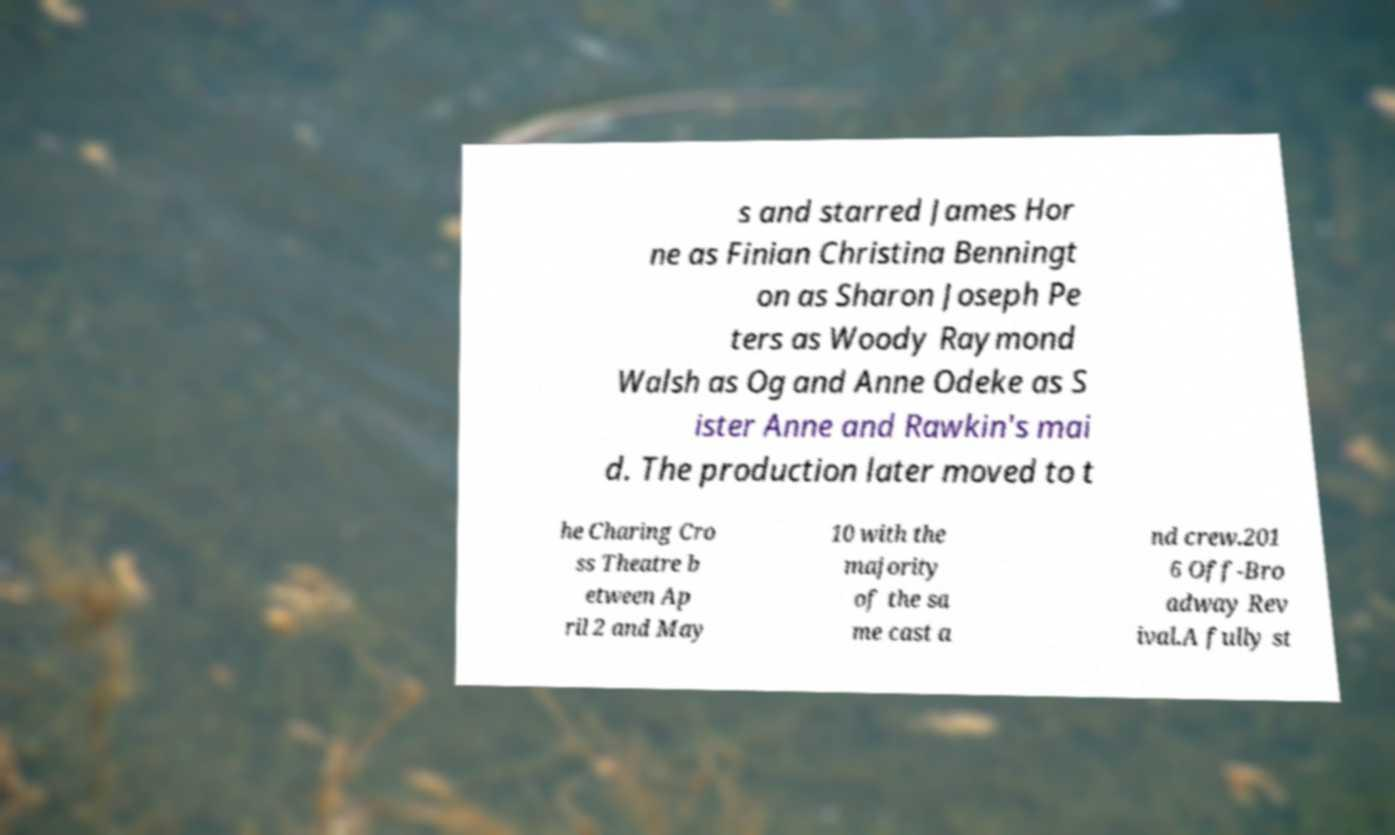Could you assist in decoding the text presented in this image and type it out clearly? s and starred James Hor ne as Finian Christina Benningt on as Sharon Joseph Pe ters as Woody Raymond Walsh as Og and Anne Odeke as S ister Anne and Rawkin's mai d. The production later moved to t he Charing Cro ss Theatre b etween Ap ril 2 and May 10 with the majority of the sa me cast a nd crew.201 6 Off-Bro adway Rev ival.A fully st 